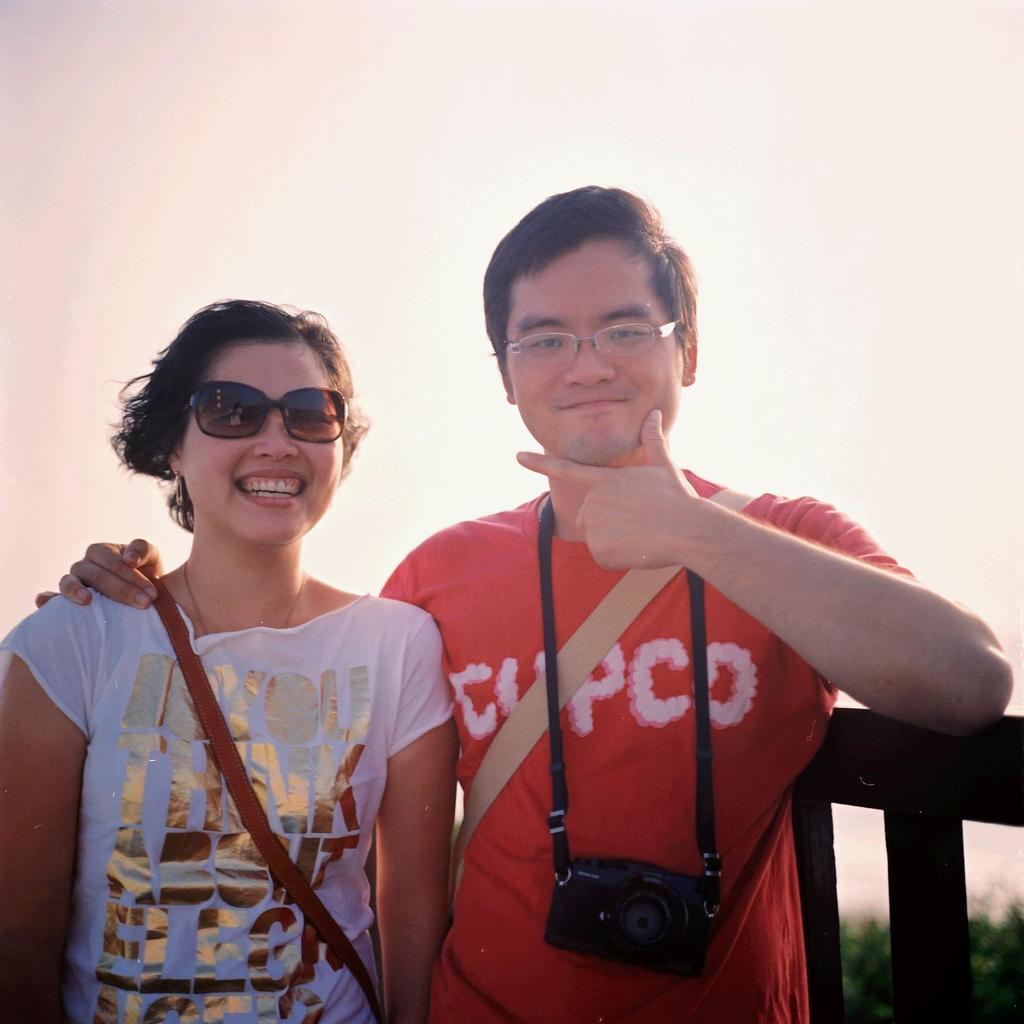Describe this image in one or two sentences. In this image I can see two people with red and white color dresses. I can see one person with the camera. To the side I can see the railing. In the background I can see the trees and the sky. 